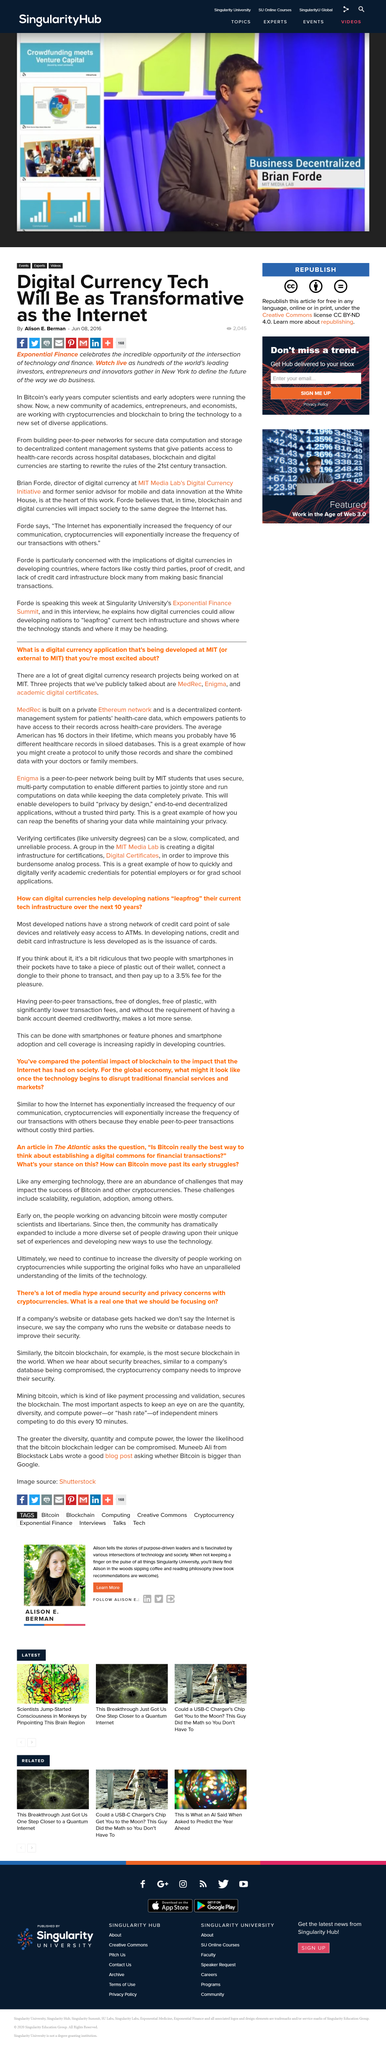List a handful of essential elements in this visual. Alison E. Berman wrote the article "Digital Currency Tech Will Be as Transformative as the Internet. Developing countries lack the necessary credit and debit card infrastructure to support economic growth and development. The Exponential Finance event was held in New York. Smartphones can be used to make peer-to-peer transactions through the use of technology. Brian Forde is leading the work that will make digital currency technology as transformative as the internet. 